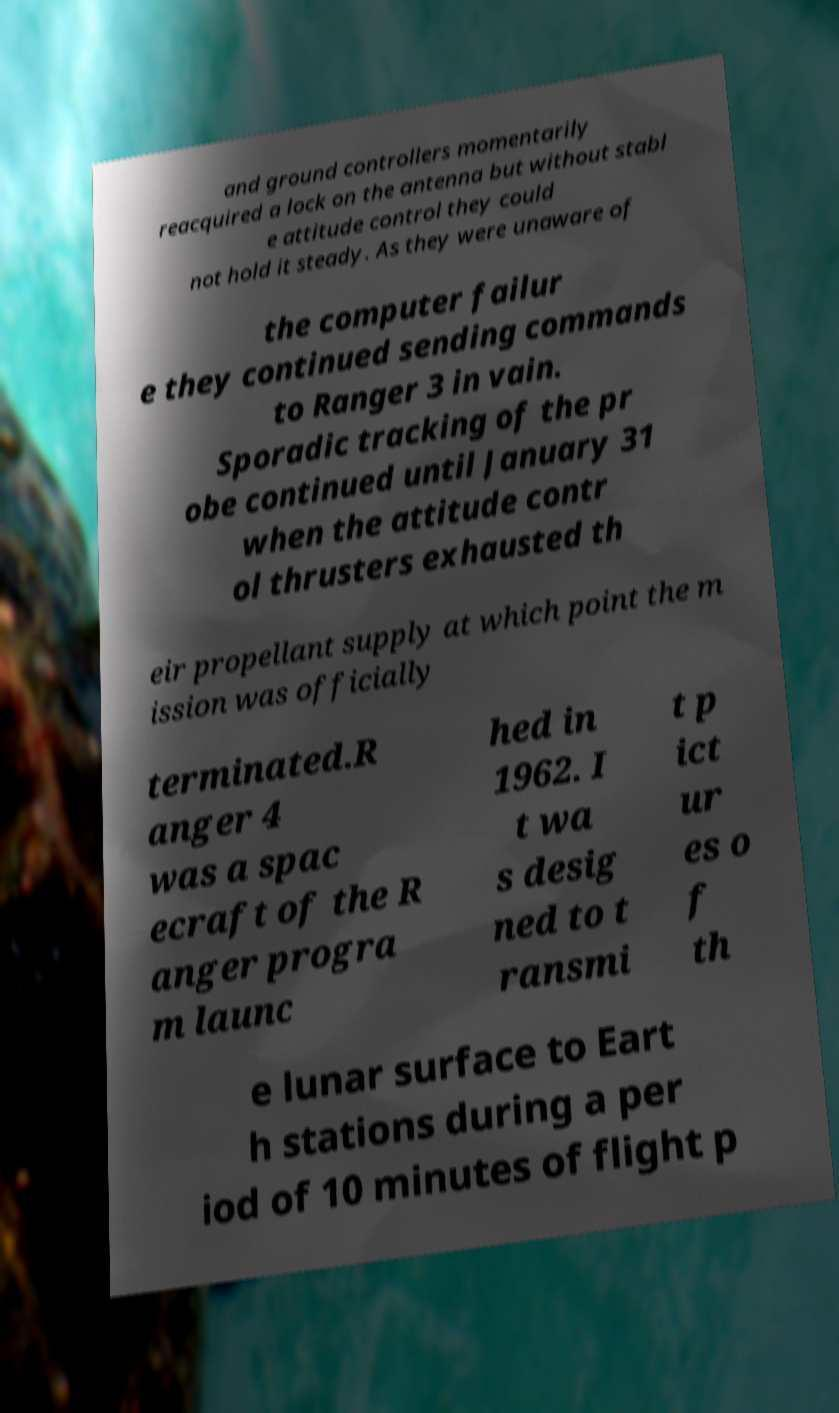For documentation purposes, I need the text within this image transcribed. Could you provide that? and ground controllers momentarily reacquired a lock on the antenna but without stabl e attitude control they could not hold it steady. As they were unaware of the computer failur e they continued sending commands to Ranger 3 in vain. Sporadic tracking of the pr obe continued until January 31 when the attitude contr ol thrusters exhausted th eir propellant supply at which point the m ission was officially terminated.R anger 4 was a spac ecraft of the R anger progra m launc hed in 1962. I t wa s desig ned to t ransmi t p ict ur es o f th e lunar surface to Eart h stations during a per iod of 10 minutes of flight p 